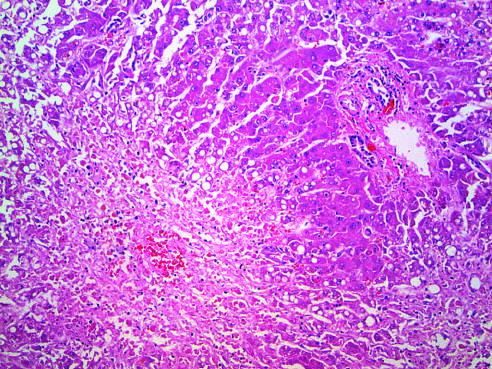how is hepatocellular necrosis caused?
Answer the question using a single word or phrase. By acetaminophen overdose 